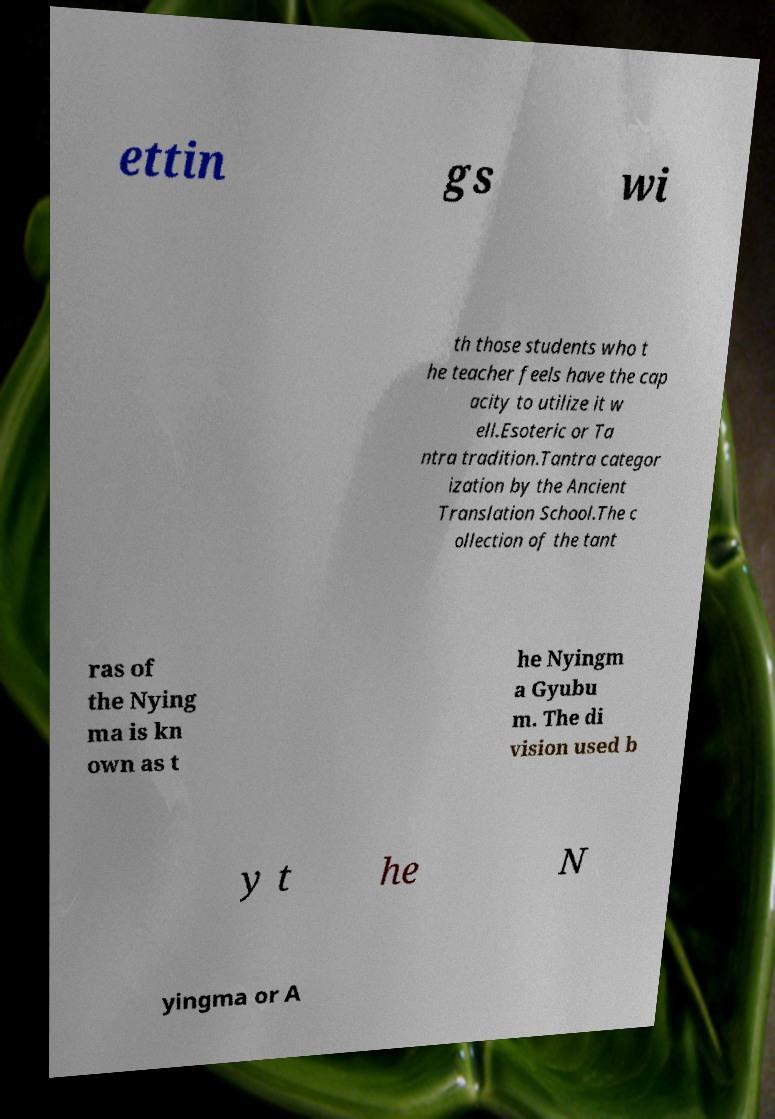I need the written content from this picture converted into text. Can you do that? ettin gs wi th those students who t he teacher feels have the cap acity to utilize it w ell.Esoteric or Ta ntra tradition.Tantra categor ization by the Ancient Translation School.The c ollection of the tant ras of the Nying ma is kn own as t he Nyingm a Gyubu m. The di vision used b y t he N yingma or A 